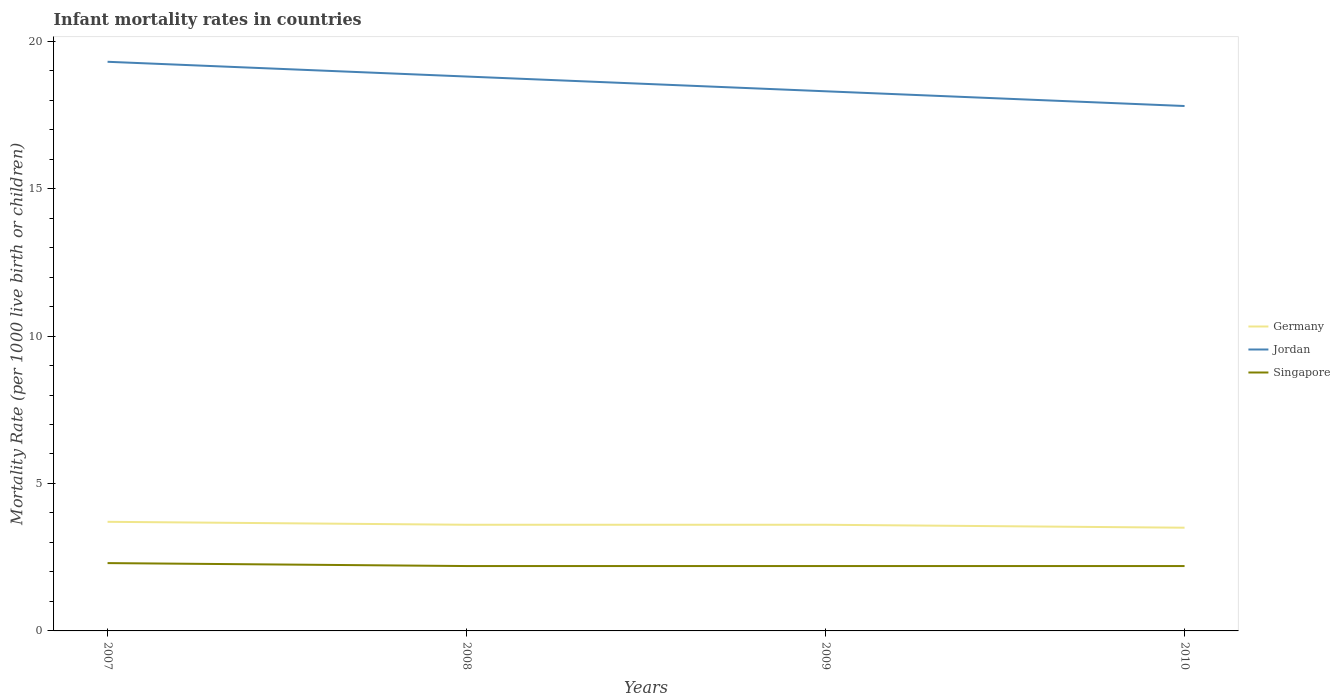Does the line corresponding to Jordan intersect with the line corresponding to Germany?
Offer a terse response. No. Across all years, what is the maximum infant mortality rate in Singapore?
Provide a succinct answer. 2.2. What is the total infant mortality rate in Germany in the graph?
Offer a terse response. 0.1. What is the difference between the highest and the second highest infant mortality rate in Singapore?
Offer a very short reply. 0.1. Is the infant mortality rate in Singapore strictly greater than the infant mortality rate in Jordan over the years?
Make the answer very short. Yes. Are the values on the major ticks of Y-axis written in scientific E-notation?
Your answer should be compact. No. Does the graph contain grids?
Offer a terse response. No. How many legend labels are there?
Offer a terse response. 3. What is the title of the graph?
Your answer should be compact. Infant mortality rates in countries. What is the label or title of the Y-axis?
Ensure brevity in your answer.  Mortality Rate (per 1000 live birth or children). What is the Mortality Rate (per 1000 live birth or children) of Jordan in 2007?
Offer a very short reply. 19.3. What is the Mortality Rate (per 1000 live birth or children) of Jordan in 2009?
Give a very brief answer. 18.3. What is the Mortality Rate (per 1000 live birth or children) in Germany in 2010?
Your response must be concise. 3.5. What is the Mortality Rate (per 1000 live birth or children) of Singapore in 2010?
Offer a very short reply. 2.2. Across all years, what is the maximum Mortality Rate (per 1000 live birth or children) in Jordan?
Keep it short and to the point. 19.3. Across all years, what is the minimum Mortality Rate (per 1000 live birth or children) of Germany?
Give a very brief answer. 3.5. Across all years, what is the minimum Mortality Rate (per 1000 live birth or children) in Jordan?
Your response must be concise. 17.8. What is the total Mortality Rate (per 1000 live birth or children) of Jordan in the graph?
Give a very brief answer. 74.2. What is the total Mortality Rate (per 1000 live birth or children) in Singapore in the graph?
Your answer should be compact. 8.9. What is the difference between the Mortality Rate (per 1000 live birth or children) in Singapore in 2007 and that in 2008?
Offer a terse response. 0.1. What is the difference between the Mortality Rate (per 1000 live birth or children) of Singapore in 2007 and that in 2009?
Offer a terse response. 0.1. What is the difference between the Mortality Rate (per 1000 live birth or children) in Jordan in 2007 and that in 2010?
Keep it short and to the point. 1.5. What is the difference between the Mortality Rate (per 1000 live birth or children) of Jordan in 2008 and that in 2009?
Offer a terse response. 0.5. What is the difference between the Mortality Rate (per 1000 live birth or children) in Singapore in 2008 and that in 2009?
Provide a short and direct response. 0. What is the difference between the Mortality Rate (per 1000 live birth or children) in Germany in 2008 and that in 2010?
Your answer should be compact. 0.1. What is the difference between the Mortality Rate (per 1000 live birth or children) of Germany in 2009 and that in 2010?
Ensure brevity in your answer.  0.1. What is the difference between the Mortality Rate (per 1000 live birth or children) in Jordan in 2009 and that in 2010?
Your response must be concise. 0.5. What is the difference between the Mortality Rate (per 1000 live birth or children) in Singapore in 2009 and that in 2010?
Provide a short and direct response. 0. What is the difference between the Mortality Rate (per 1000 live birth or children) in Germany in 2007 and the Mortality Rate (per 1000 live birth or children) in Jordan in 2008?
Provide a short and direct response. -15.1. What is the difference between the Mortality Rate (per 1000 live birth or children) of Jordan in 2007 and the Mortality Rate (per 1000 live birth or children) of Singapore in 2008?
Offer a terse response. 17.1. What is the difference between the Mortality Rate (per 1000 live birth or children) of Germany in 2007 and the Mortality Rate (per 1000 live birth or children) of Jordan in 2009?
Ensure brevity in your answer.  -14.6. What is the difference between the Mortality Rate (per 1000 live birth or children) of Germany in 2007 and the Mortality Rate (per 1000 live birth or children) of Jordan in 2010?
Provide a short and direct response. -14.1. What is the difference between the Mortality Rate (per 1000 live birth or children) in Germany in 2007 and the Mortality Rate (per 1000 live birth or children) in Singapore in 2010?
Make the answer very short. 1.5. What is the difference between the Mortality Rate (per 1000 live birth or children) in Jordan in 2007 and the Mortality Rate (per 1000 live birth or children) in Singapore in 2010?
Make the answer very short. 17.1. What is the difference between the Mortality Rate (per 1000 live birth or children) in Germany in 2008 and the Mortality Rate (per 1000 live birth or children) in Jordan in 2009?
Ensure brevity in your answer.  -14.7. What is the difference between the Mortality Rate (per 1000 live birth or children) in Germany in 2008 and the Mortality Rate (per 1000 live birth or children) in Singapore in 2010?
Your answer should be compact. 1.4. What is the difference between the Mortality Rate (per 1000 live birth or children) of Jordan in 2008 and the Mortality Rate (per 1000 live birth or children) of Singapore in 2010?
Provide a succinct answer. 16.6. What is the difference between the Mortality Rate (per 1000 live birth or children) in Germany in 2009 and the Mortality Rate (per 1000 live birth or children) in Jordan in 2010?
Ensure brevity in your answer.  -14.2. What is the difference between the Mortality Rate (per 1000 live birth or children) in Germany in 2009 and the Mortality Rate (per 1000 live birth or children) in Singapore in 2010?
Keep it short and to the point. 1.4. What is the difference between the Mortality Rate (per 1000 live birth or children) in Jordan in 2009 and the Mortality Rate (per 1000 live birth or children) in Singapore in 2010?
Offer a very short reply. 16.1. What is the average Mortality Rate (per 1000 live birth or children) of Jordan per year?
Your answer should be very brief. 18.55. What is the average Mortality Rate (per 1000 live birth or children) in Singapore per year?
Keep it short and to the point. 2.23. In the year 2007, what is the difference between the Mortality Rate (per 1000 live birth or children) in Germany and Mortality Rate (per 1000 live birth or children) in Jordan?
Keep it short and to the point. -15.6. In the year 2008, what is the difference between the Mortality Rate (per 1000 live birth or children) in Germany and Mortality Rate (per 1000 live birth or children) in Jordan?
Provide a short and direct response. -15.2. In the year 2009, what is the difference between the Mortality Rate (per 1000 live birth or children) in Germany and Mortality Rate (per 1000 live birth or children) in Jordan?
Provide a short and direct response. -14.7. In the year 2009, what is the difference between the Mortality Rate (per 1000 live birth or children) of Germany and Mortality Rate (per 1000 live birth or children) of Singapore?
Offer a terse response. 1.4. In the year 2009, what is the difference between the Mortality Rate (per 1000 live birth or children) in Jordan and Mortality Rate (per 1000 live birth or children) in Singapore?
Offer a terse response. 16.1. In the year 2010, what is the difference between the Mortality Rate (per 1000 live birth or children) of Germany and Mortality Rate (per 1000 live birth or children) of Jordan?
Give a very brief answer. -14.3. In the year 2010, what is the difference between the Mortality Rate (per 1000 live birth or children) of Jordan and Mortality Rate (per 1000 live birth or children) of Singapore?
Your response must be concise. 15.6. What is the ratio of the Mortality Rate (per 1000 live birth or children) of Germany in 2007 to that in 2008?
Your response must be concise. 1.03. What is the ratio of the Mortality Rate (per 1000 live birth or children) of Jordan in 2007 to that in 2008?
Ensure brevity in your answer.  1.03. What is the ratio of the Mortality Rate (per 1000 live birth or children) in Singapore in 2007 to that in 2008?
Offer a terse response. 1.05. What is the ratio of the Mortality Rate (per 1000 live birth or children) in Germany in 2007 to that in 2009?
Provide a short and direct response. 1.03. What is the ratio of the Mortality Rate (per 1000 live birth or children) in Jordan in 2007 to that in 2009?
Your answer should be compact. 1.05. What is the ratio of the Mortality Rate (per 1000 live birth or children) of Singapore in 2007 to that in 2009?
Keep it short and to the point. 1.05. What is the ratio of the Mortality Rate (per 1000 live birth or children) of Germany in 2007 to that in 2010?
Keep it short and to the point. 1.06. What is the ratio of the Mortality Rate (per 1000 live birth or children) of Jordan in 2007 to that in 2010?
Ensure brevity in your answer.  1.08. What is the ratio of the Mortality Rate (per 1000 live birth or children) of Singapore in 2007 to that in 2010?
Your response must be concise. 1.05. What is the ratio of the Mortality Rate (per 1000 live birth or children) of Germany in 2008 to that in 2009?
Make the answer very short. 1. What is the ratio of the Mortality Rate (per 1000 live birth or children) in Jordan in 2008 to that in 2009?
Ensure brevity in your answer.  1.03. What is the ratio of the Mortality Rate (per 1000 live birth or children) of Germany in 2008 to that in 2010?
Offer a terse response. 1.03. What is the ratio of the Mortality Rate (per 1000 live birth or children) in Jordan in 2008 to that in 2010?
Offer a very short reply. 1.06. What is the ratio of the Mortality Rate (per 1000 live birth or children) in Germany in 2009 to that in 2010?
Offer a very short reply. 1.03. What is the ratio of the Mortality Rate (per 1000 live birth or children) of Jordan in 2009 to that in 2010?
Keep it short and to the point. 1.03. What is the ratio of the Mortality Rate (per 1000 live birth or children) of Singapore in 2009 to that in 2010?
Your answer should be compact. 1. What is the difference between the highest and the second highest Mortality Rate (per 1000 live birth or children) of Singapore?
Keep it short and to the point. 0.1. 